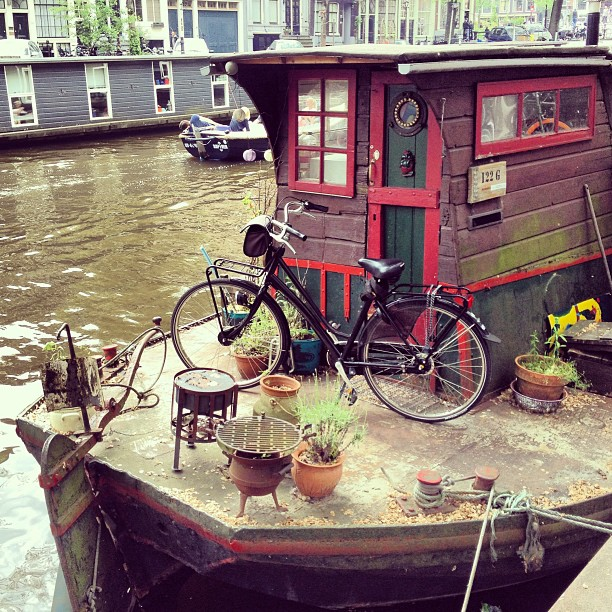What are some activities one might enjoy near this houseboat setting? This idyllic setting is perfect for relaxing by the waterside, indulging in some fishing, reading a book on the deck, or enjoying a cup of coffee while watching the boats go by. It’s an inviting environment for leisure and tranquility. 